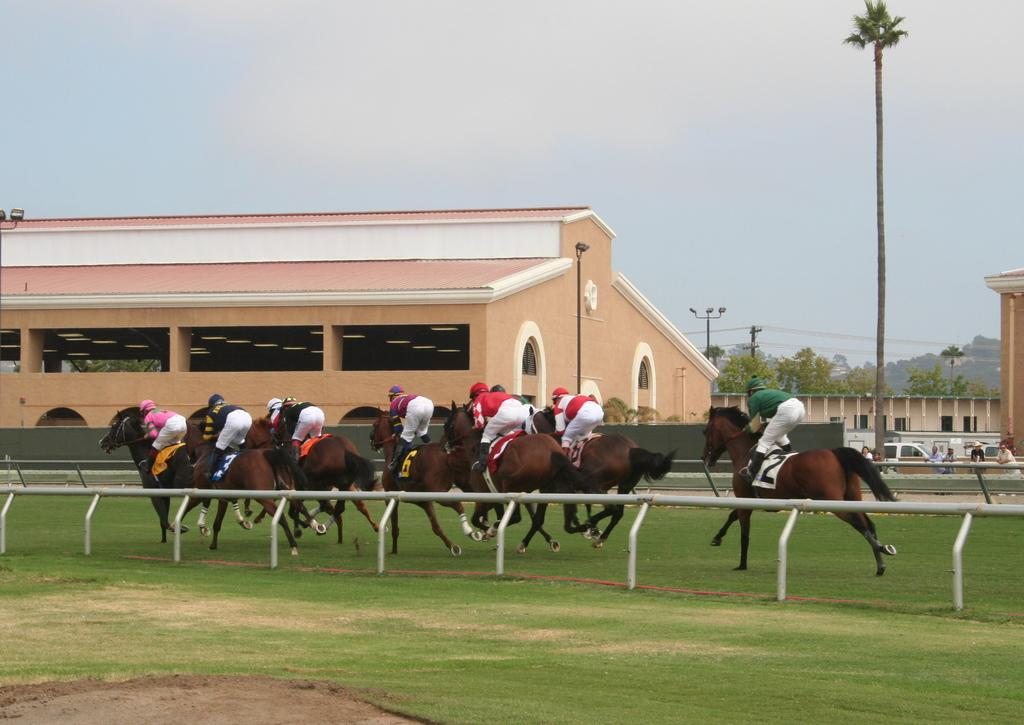What are the persons in the image doing? The persons in the image are riding on horses. What can be seen beneath the horses in the image? The ground is visible in the image. What is visible at the top of the image? There is sky visible at the top of the image. What type of structure can be seen in the image? There is at least one building in the image. What type of vegetation is present in the image? Trees are present in the image. What else can be seen in the image besides the horses and riders? Poles are visible in the image. What type of writing can be seen on the horses in the image? There is no writing visible on the horses in the image. How does the behavior of the horses change throughout the image? The behavior of the horses cannot be determined from the image, as it only shows a single moment in time. 